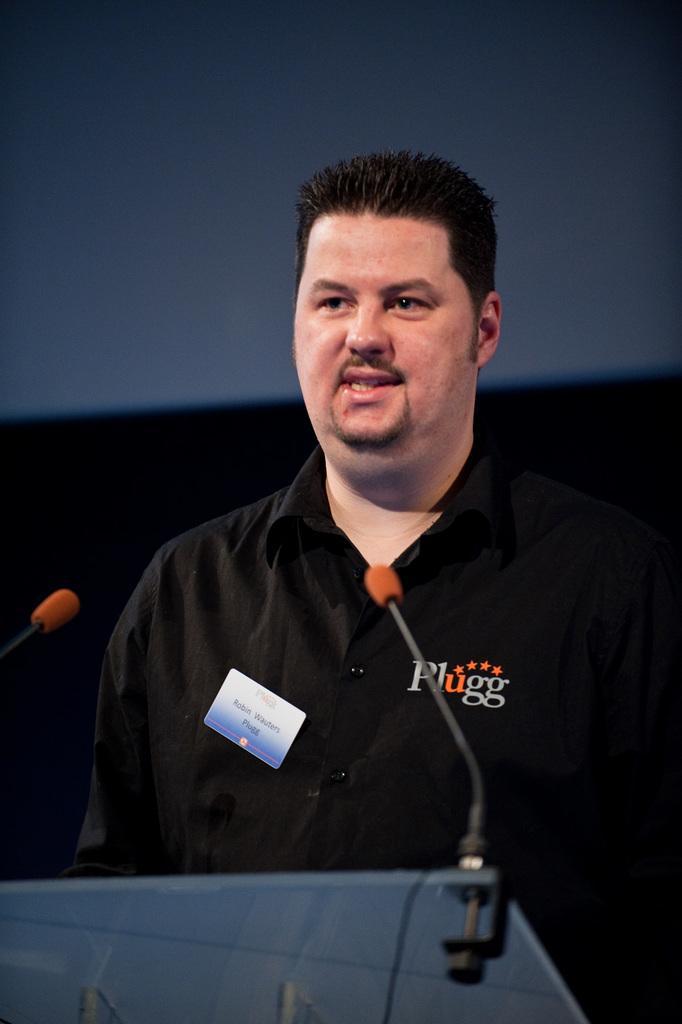In one or two sentences, can you explain what this image depicts? In this picture a man standing at a podium and speaking with the help of microphones and I can see a name batch to his shirt on the left side and text on the right side of his shirt. 